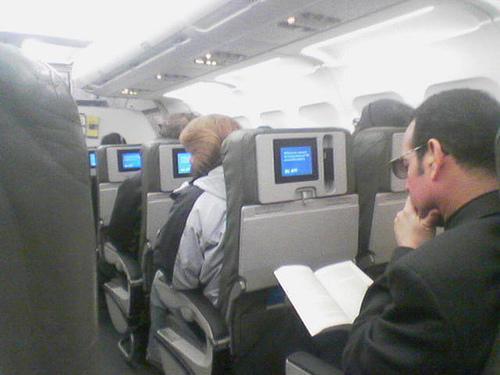How many people are there?
Give a very brief answer. 3. How many kites are flying?
Give a very brief answer. 0. 